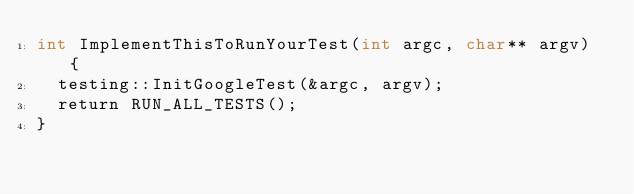<code> <loc_0><loc_0><loc_500><loc_500><_ObjectiveC_>int ImplementThisToRunYourTest(int argc, char** argv) {
  testing::InitGoogleTest(&argc, argv);
  return RUN_ALL_TESTS();
}
</code> 